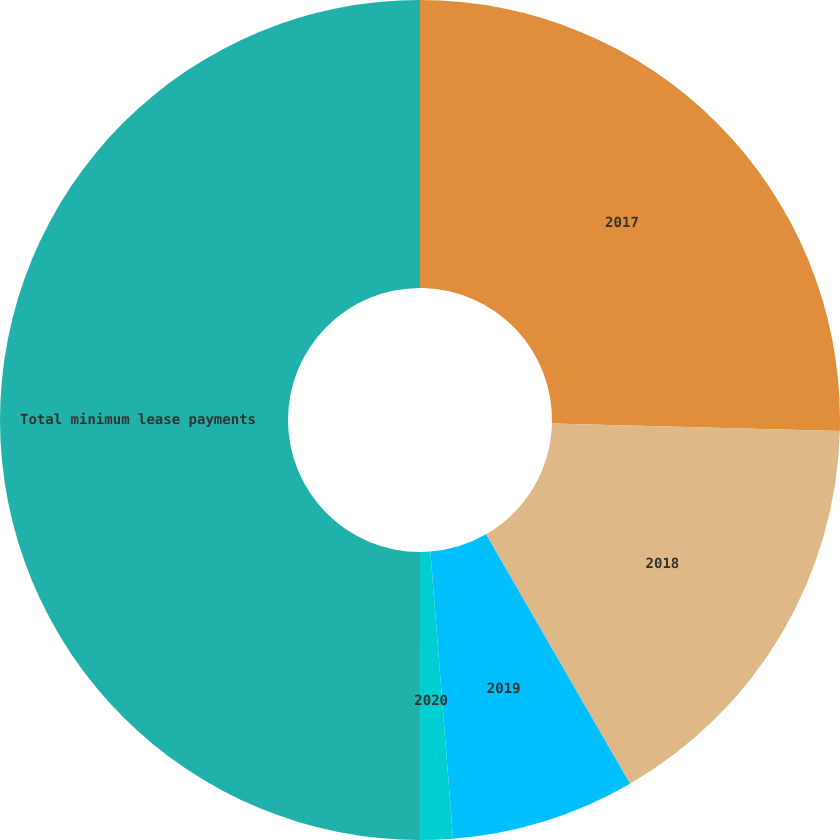<chart> <loc_0><loc_0><loc_500><loc_500><pie_chart><fcel>2017<fcel>2018<fcel>2019<fcel>2020<fcel>Total minimum lease payments<nl><fcel>25.41%<fcel>16.25%<fcel>7.08%<fcel>1.25%<fcel>50.0%<nl></chart> 